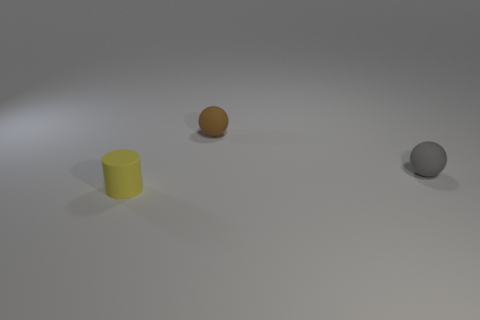Is there another small rubber thing of the same shape as the brown rubber object?
Keep it short and to the point. Yes. There is a ball that is to the left of the small gray matte thing to the right of the small object behind the small gray object; what is its color?
Give a very brief answer. Brown. What number of metal things are either small brown spheres or green blocks?
Keep it short and to the point. 0. Is the number of gray spheres that are to the left of the tiny brown thing greater than the number of yellow rubber things that are right of the gray thing?
Offer a terse response. No. How big is the rubber ball that is to the right of the tiny rubber ball that is left of the gray thing?
Give a very brief answer. Small. What number of small objects are either rubber balls or cylinders?
Give a very brief answer. 3. There is a ball in front of the small matte ball behind the matte ball in front of the small brown rubber sphere; how big is it?
Offer a terse response. Small. Are there any other things of the same color as the cylinder?
Offer a terse response. No. There is a tiny thing behind the small ball that is in front of the tiny sphere that is behind the small gray ball; what is it made of?
Your answer should be compact. Rubber. Is the brown matte thing the same shape as the yellow rubber object?
Make the answer very short. No. 